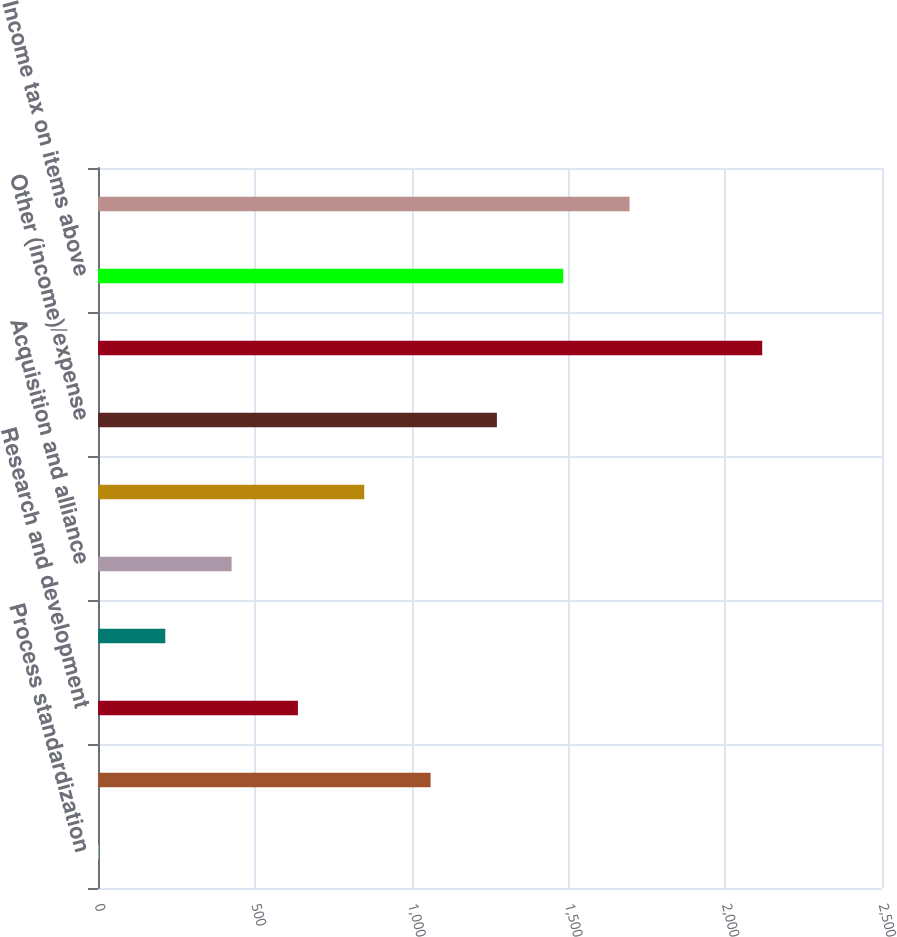Convert chart to OTSL. <chart><loc_0><loc_0><loc_500><loc_500><bar_chart><fcel>Process standardization<fcel>Marketing selling and<fcel>Research and development<fcel>Provision for restructuring<fcel>Acquisition and alliance<fcel>Litigation<fcel>Other (income)/expense<fcel>Increase to pretax income<fcel>Income tax on items above<fcel>Income taxes<nl><fcel>3<fcel>1060.5<fcel>637.5<fcel>214.5<fcel>426<fcel>849<fcel>1272<fcel>2118<fcel>1483.5<fcel>1695<nl></chart> 